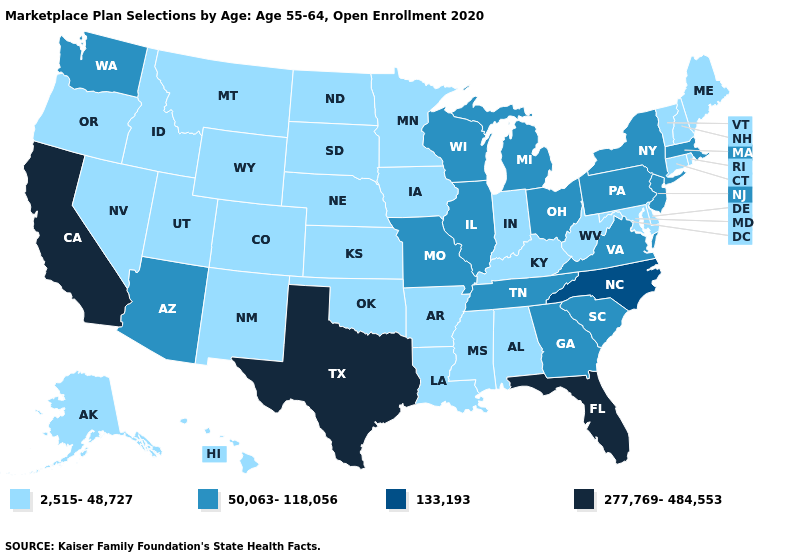Name the states that have a value in the range 133,193?
Quick response, please. North Carolina. Does West Virginia have a lower value than Alaska?
Answer briefly. No. Name the states that have a value in the range 133,193?
Answer briefly. North Carolina. Name the states that have a value in the range 50,063-118,056?
Keep it brief. Arizona, Georgia, Illinois, Massachusetts, Michigan, Missouri, New Jersey, New York, Ohio, Pennsylvania, South Carolina, Tennessee, Virginia, Washington, Wisconsin. Name the states that have a value in the range 2,515-48,727?
Answer briefly. Alabama, Alaska, Arkansas, Colorado, Connecticut, Delaware, Hawaii, Idaho, Indiana, Iowa, Kansas, Kentucky, Louisiana, Maine, Maryland, Minnesota, Mississippi, Montana, Nebraska, Nevada, New Hampshire, New Mexico, North Dakota, Oklahoma, Oregon, Rhode Island, South Dakota, Utah, Vermont, West Virginia, Wyoming. What is the highest value in the Northeast ?
Quick response, please. 50,063-118,056. What is the lowest value in the West?
Give a very brief answer. 2,515-48,727. Which states have the highest value in the USA?
Answer briefly. California, Florida, Texas. Is the legend a continuous bar?
Concise answer only. No. Which states have the highest value in the USA?
Quick response, please. California, Florida, Texas. Name the states that have a value in the range 277,769-484,553?
Give a very brief answer. California, Florida, Texas. What is the value of Ohio?
Concise answer only. 50,063-118,056. What is the lowest value in the USA?
Be succinct. 2,515-48,727. Does the first symbol in the legend represent the smallest category?
Answer briefly. Yes. Does Missouri have the highest value in the MidWest?
Quick response, please. Yes. 